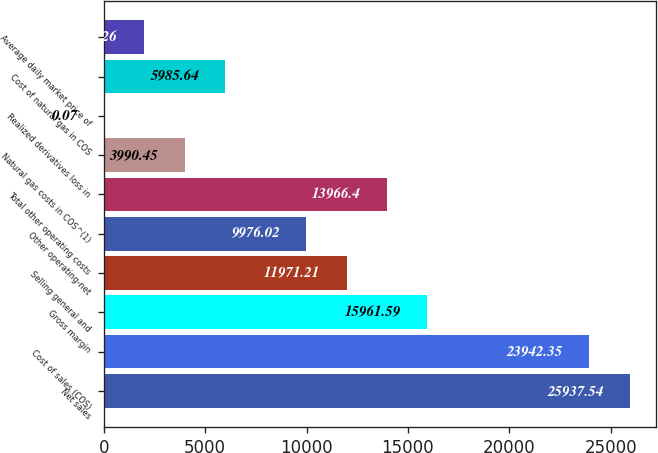Convert chart. <chart><loc_0><loc_0><loc_500><loc_500><bar_chart><fcel>Net sales<fcel>Cost of sales (COS)<fcel>Gross margin<fcel>Selling general and<fcel>Other operating-net<fcel>Total other operating costs<fcel>Natural gas costs in COS^(1)<fcel>Realized derivatives loss in<fcel>Cost of natural gas in COS<fcel>Average daily market price of<nl><fcel>25937.5<fcel>23942.3<fcel>15961.6<fcel>11971.2<fcel>9976.02<fcel>13966.4<fcel>3990.45<fcel>0.07<fcel>5985.64<fcel>1995.26<nl></chart> 